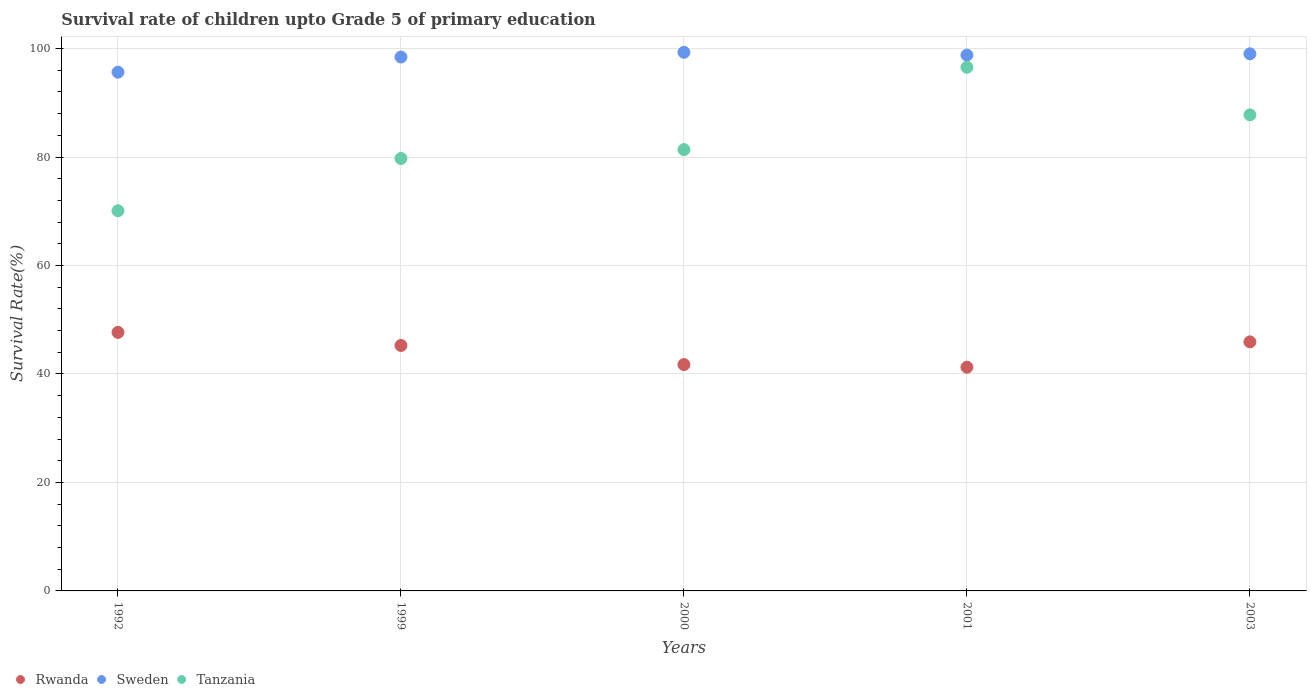What is the survival rate of children in Sweden in 2001?
Make the answer very short. 98.79. Across all years, what is the maximum survival rate of children in Tanzania?
Provide a short and direct response. 96.54. Across all years, what is the minimum survival rate of children in Rwanda?
Your response must be concise. 41.25. What is the total survival rate of children in Sweden in the graph?
Make the answer very short. 491.19. What is the difference between the survival rate of children in Sweden in 1992 and that in 2000?
Provide a succinct answer. -3.66. What is the difference between the survival rate of children in Rwanda in 1992 and the survival rate of children in Tanzania in 1999?
Keep it short and to the point. -32.06. What is the average survival rate of children in Tanzania per year?
Provide a short and direct response. 83.1. In the year 1992, what is the difference between the survival rate of children in Rwanda and survival rate of children in Sweden?
Your response must be concise. -47.97. In how many years, is the survival rate of children in Rwanda greater than 12 %?
Your answer should be compact. 5. What is the ratio of the survival rate of children in Tanzania in 2000 to that in 2003?
Make the answer very short. 0.93. What is the difference between the highest and the second highest survival rate of children in Rwanda?
Provide a succinct answer. 1.75. What is the difference between the highest and the lowest survival rate of children in Tanzania?
Give a very brief answer. 26.45. In how many years, is the survival rate of children in Sweden greater than the average survival rate of children in Sweden taken over all years?
Offer a terse response. 4. Is the sum of the survival rate of children in Tanzania in 1999 and 2000 greater than the maximum survival rate of children in Rwanda across all years?
Ensure brevity in your answer.  Yes. Is the survival rate of children in Tanzania strictly greater than the survival rate of children in Sweden over the years?
Make the answer very short. No. Is the survival rate of children in Tanzania strictly less than the survival rate of children in Sweden over the years?
Your response must be concise. Yes. How many dotlines are there?
Provide a succinct answer. 3. Does the graph contain grids?
Offer a terse response. Yes. How are the legend labels stacked?
Your answer should be very brief. Horizontal. What is the title of the graph?
Provide a succinct answer. Survival rate of children upto Grade 5 of primary education. What is the label or title of the Y-axis?
Your answer should be very brief. Survival Rate(%). What is the Survival Rate(%) in Rwanda in 1992?
Offer a terse response. 47.67. What is the Survival Rate(%) of Sweden in 1992?
Your response must be concise. 95.64. What is the Survival Rate(%) of Tanzania in 1992?
Provide a short and direct response. 70.09. What is the Survival Rate(%) of Rwanda in 1999?
Your answer should be compact. 45.26. What is the Survival Rate(%) of Sweden in 1999?
Your answer should be very brief. 98.43. What is the Survival Rate(%) in Tanzania in 1999?
Your answer should be compact. 79.73. What is the Survival Rate(%) in Rwanda in 2000?
Provide a succinct answer. 41.73. What is the Survival Rate(%) of Sweden in 2000?
Give a very brief answer. 99.3. What is the Survival Rate(%) in Tanzania in 2000?
Your response must be concise. 81.36. What is the Survival Rate(%) of Rwanda in 2001?
Offer a very short reply. 41.25. What is the Survival Rate(%) in Sweden in 2001?
Keep it short and to the point. 98.79. What is the Survival Rate(%) of Tanzania in 2001?
Provide a succinct answer. 96.54. What is the Survival Rate(%) in Rwanda in 2003?
Your answer should be compact. 45.92. What is the Survival Rate(%) of Sweden in 2003?
Make the answer very short. 99.02. What is the Survival Rate(%) of Tanzania in 2003?
Provide a short and direct response. 87.77. Across all years, what is the maximum Survival Rate(%) in Rwanda?
Provide a succinct answer. 47.67. Across all years, what is the maximum Survival Rate(%) in Sweden?
Offer a very short reply. 99.3. Across all years, what is the maximum Survival Rate(%) in Tanzania?
Offer a terse response. 96.54. Across all years, what is the minimum Survival Rate(%) of Rwanda?
Give a very brief answer. 41.25. Across all years, what is the minimum Survival Rate(%) in Sweden?
Your response must be concise. 95.64. Across all years, what is the minimum Survival Rate(%) in Tanzania?
Your answer should be very brief. 70.09. What is the total Survival Rate(%) of Rwanda in the graph?
Offer a terse response. 221.82. What is the total Survival Rate(%) of Sweden in the graph?
Ensure brevity in your answer.  491.19. What is the total Survival Rate(%) of Tanzania in the graph?
Offer a very short reply. 415.49. What is the difference between the Survival Rate(%) of Rwanda in 1992 and that in 1999?
Provide a short and direct response. 2.41. What is the difference between the Survival Rate(%) in Sweden in 1992 and that in 1999?
Provide a short and direct response. -2.79. What is the difference between the Survival Rate(%) of Tanzania in 1992 and that in 1999?
Your response must be concise. -9.64. What is the difference between the Survival Rate(%) of Rwanda in 1992 and that in 2000?
Offer a terse response. 5.93. What is the difference between the Survival Rate(%) of Sweden in 1992 and that in 2000?
Provide a succinct answer. -3.66. What is the difference between the Survival Rate(%) of Tanzania in 1992 and that in 2000?
Provide a succinct answer. -11.27. What is the difference between the Survival Rate(%) in Rwanda in 1992 and that in 2001?
Give a very brief answer. 6.42. What is the difference between the Survival Rate(%) of Sweden in 1992 and that in 2001?
Provide a short and direct response. -3.15. What is the difference between the Survival Rate(%) in Tanzania in 1992 and that in 2001?
Provide a short and direct response. -26.45. What is the difference between the Survival Rate(%) of Rwanda in 1992 and that in 2003?
Provide a short and direct response. 1.75. What is the difference between the Survival Rate(%) of Sweden in 1992 and that in 2003?
Offer a very short reply. -3.38. What is the difference between the Survival Rate(%) in Tanzania in 1992 and that in 2003?
Your answer should be very brief. -17.68. What is the difference between the Survival Rate(%) in Rwanda in 1999 and that in 2000?
Keep it short and to the point. 3.52. What is the difference between the Survival Rate(%) in Sweden in 1999 and that in 2000?
Provide a short and direct response. -0.87. What is the difference between the Survival Rate(%) of Tanzania in 1999 and that in 2000?
Provide a succinct answer. -1.63. What is the difference between the Survival Rate(%) in Rwanda in 1999 and that in 2001?
Provide a short and direct response. 4.01. What is the difference between the Survival Rate(%) in Sweden in 1999 and that in 2001?
Offer a very short reply. -0.36. What is the difference between the Survival Rate(%) in Tanzania in 1999 and that in 2001?
Your response must be concise. -16.81. What is the difference between the Survival Rate(%) in Rwanda in 1999 and that in 2003?
Provide a short and direct response. -0.66. What is the difference between the Survival Rate(%) of Sweden in 1999 and that in 2003?
Provide a succinct answer. -0.59. What is the difference between the Survival Rate(%) in Tanzania in 1999 and that in 2003?
Offer a terse response. -8.04. What is the difference between the Survival Rate(%) in Rwanda in 2000 and that in 2001?
Make the answer very short. 0.48. What is the difference between the Survival Rate(%) in Sweden in 2000 and that in 2001?
Your answer should be very brief. 0.51. What is the difference between the Survival Rate(%) in Tanzania in 2000 and that in 2001?
Your answer should be very brief. -15.18. What is the difference between the Survival Rate(%) of Rwanda in 2000 and that in 2003?
Make the answer very short. -4.18. What is the difference between the Survival Rate(%) in Sweden in 2000 and that in 2003?
Provide a succinct answer. 0.28. What is the difference between the Survival Rate(%) in Tanzania in 2000 and that in 2003?
Keep it short and to the point. -6.41. What is the difference between the Survival Rate(%) in Rwanda in 2001 and that in 2003?
Your answer should be very brief. -4.67. What is the difference between the Survival Rate(%) of Sweden in 2001 and that in 2003?
Give a very brief answer. -0.24. What is the difference between the Survival Rate(%) of Tanzania in 2001 and that in 2003?
Your response must be concise. 8.77. What is the difference between the Survival Rate(%) in Rwanda in 1992 and the Survival Rate(%) in Sweden in 1999?
Provide a short and direct response. -50.77. What is the difference between the Survival Rate(%) of Rwanda in 1992 and the Survival Rate(%) of Tanzania in 1999?
Ensure brevity in your answer.  -32.06. What is the difference between the Survival Rate(%) in Sweden in 1992 and the Survival Rate(%) in Tanzania in 1999?
Give a very brief answer. 15.91. What is the difference between the Survival Rate(%) in Rwanda in 1992 and the Survival Rate(%) in Sweden in 2000?
Your answer should be very brief. -51.63. What is the difference between the Survival Rate(%) in Rwanda in 1992 and the Survival Rate(%) in Tanzania in 2000?
Provide a succinct answer. -33.69. What is the difference between the Survival Rate(%) of Sweden in 1992 and the Survival Rate(%) of Tanzania in 2000?
Offer a terse response. 14.28. What is the difference between the Survival Rate(%) of Rwanda in 1992 and the Survival Rate(%) of Sweden in 2001?
Your answer should be very brief. -51.12. What is the difference between the Survival Rate(%) of Rwanda in 1992 and the Survival Rate(%) of Tanzania in 2001?
Ensure brevity in your answer.  -48.88. What is the difference between the Survival Rate(%) in Sweden in 1992 and the Survival Rate(%) in Tanzania in 2001?
Offer a terse response. -0.9. What is the difference between the Survival Rate(%) in Rwanda in 1992 and the Survival Rate(%) in Sweden in 2003?
Your answer should be compact. -51.36. What is the difference between the Survival Rate(%) of Rwanda in 1992 and the Survival Rate(%) of Tanzania in 2003?
Make the answer very short. -40.1. What is the difference between the Survival Rate(%) in Sweden in 1992 and the Survival Rate(%) in Tanzania in 2003?
Provide a short and direct response. 7.87. What is the difference between the Survival Rate(%) in Rwanda in 1999 and the Survival Rate(%) in Sweden in 2000?
Offer a very short reply. -54.04. What is the difference between the Survival Rate(%) in Rwanda in 1999 and the Survival Rate(%) in Tanzania in 2000?
Provide a succinct answer. -36.1. What is the difference between the Survival Rate(%) in Sweden in 1999 and the Survival Rate(%) in Tanzania in 2000?
Provide a short and direct response. 17.07. What is the difference between the Survival Rate(%) of Rwanda in 1999 and the Survival Rate(%) of Sweden in 2001?
Your answer should be compact. -53.53. What is the difference between the Survival Rate(%) in Rwanda in 1999 and the Survival Rate(%) in Tanzania in 2001?
Your answer should be very brief. -51.29. What is the difference between the Survival Rate(%) in Sweden in 1999 and the Survival Rate(%) in Tanzania in 2001?
Make the answer very short. 1.89. What is the difference between the Survival Rate(%) of Rwanda in 1999 and the Survival Rate(%) of Sweden in 2003?
Keep it short and to the point. -53.77. What is the difference between the Survival Rate(%) in Rwanda in 1999 and the Survival Rate(%) in Tanzania in 2003?
Keep it short and to the point. -42.51. What is the difference between the Survival Rate(%) in Sweden in 1999 and the Survival Rate(%) in Tanzania in 2003?
Give a very brief answer. 10.67. What is the difference between the Survival Rate(%) of Rwanda in 2000 and the Survival Rate(%) of Sweden in 2001?
Your answer should be very brief. -57.06. What is the difference between the Survival Rate(%) in Rwanda in 2000 and the Survival Rate(%) in Tanzania in 2001?
Provide a short and direct response. -54.81. What is the difference between the Survival Rate(%) of Sweden in 2000 and the Survival Rate(%) of Tanzania in 2001?
Provide a short and direct response. 2.76. What is the difference between the Survival Rate(%) in Rwanda in 2000 and the Survival Rate(%) in Sweden in 2003?
Keep it short and to the point. -57.29. What is the difference between the Survival Rate(%) in Rwanda in 2000 and the Survival Rate(%) in Tanzania in 2003?
Your answer should be very brief. -46.04. What is the difference between the Survival Rate(%) of Sweden in 2000 and the Survival Rate(%) of Tanzania in 2003?
Keep it short and to the point. 11.53. What is the difference between the Survival Rate(%) of Rwanda in 2001 and the Survival Rate(%) of Sweden in 2003?
Your answer should be very brief. -57.78. What is the difference between the Survival Rate(%) in Rwanda in 2001 and the Survival Rate(%) in Tanzania in 2003?
Provide a succinct answer. -46.52. What is the difference between the Survival Rate(%) of Sweden in 2001 and the Survival Rate(%) of Tanzania in 2003?
Provide a succinct answer. 11.02. What is the average Survival Rate(%) of Rwanda per year?
Make the answer very short. 44.36. What is the average Survival Rate(%) of Sweden per year?
Ensure brevity in your answer.  98.24. What is the average Survival Rate(%) in Tanzania per year?
Provide a succinct answer. 83.1. In the year 1992, what is the difference between the Survival Rate(%) in Rwanda and Survival Rate(%) in Sweden?
Your response must be concise. -47.97. In the year 1992, what is the difference between the Survival Rate(%) in Rwanda and Survival Rate(%) in Tanzania?
Your response must be concise. -22.42. In the year 1992, what is the difference between the Survival Rate(%) in Sweden and Survival Rate(%) in Tanzania?
Ensure brevity in your answer.  25.55. In the year 1999, what is the difference between the Survival Rate(%) in Rwanda and Survival Rate(%) in Sweden?
Provide a short and direct response. -53.18. In the year 1999, what is the difference between the Survival Rate(%) of Rwanda and Survival Rate(%) of Tanzania?
Provide a short and direct response. -34.47. In the year 1999, what is the difference between the Survival Rate(%) of Sweden and Survival Rate(%) of Tanzania?
Provide a short and direct response. 18.71. In the year 2000, what is the difference between the Survival Rate(%) of Rwanda and Survival Rate(%) of Sweden?
Make the answer very short. -57.57. In the year 2000, what is the difference between the Survival Rate(%) in Rwanda and Survival Rate(%) in Tanzania?
Your response must be concise. -39.63. In the year 2000, what is the difference between the Survival Rate(%) in Sweden and Survival Rate(%) in Tanzania?
Make the answer very short. 17.94. In the year 2001, what is the difference between the Survival Rate(%) in Rwanda and Survival Rate(%) in Sweden?
Make the answer very short. -57.54. In the year 2001, what is the difference between the Survival Rate(%) of Rwanda and Survival Rate(%) of Tanzania?
Keep it short and to the point. -55.29. In the year 2001, what is the difference between the Survival Rate(%) in Sweden and Survival Rate(%) in Tanzania?
Your response must be concise. 2.25. In the year 2003, what is the difference between the Survival Rate(%) of Rwanda and Survival Rate(%) of Sweden?
Keep it short and to the point. -53.11. In the year 2003, what is the difference between the Survival Rate(%) in Rwanda and Survival Rate(%) in Tanzania?
Your response must be concise. -41.85. In the year 2003, what is the difference between the Survival Rate(%) of Sweden and Survival Rate(%) of Tanzania?
Your answer should be compact. 11.26. What is the ratio of the Survival Rate(%) of Rwanda in 1992 to that in 1999?
Ensure brevity in your answer.  1.05. What is the ratio of the Survival Rate(%) in Sweden in 1992 to that in 1999?
Your answer should be very brief. 0.97. What is the ratio of the Survival Rate(%) in Tanzania in 1992 to that in 1999?
Your answer should be very brief. 0.88. What is the ratio of the Survival Rate(%) in Rwanda in 1992 to that in 2000?
Your answer should be compact. 1.14. What is the ratio of the Survival Rate(%) in Sweden in 1992 to that in 2000?
Make the answer very short. 0.96. What is the ratio of the Survival Rate(%) in Tanzania in 1992 to that in 2000?
Make the answer very short. 0.86. What is the ratio of the Survival Rate(%) of Rwanda in 1992 to that in 2001?
Your response must be concise. 1.16. What is the ratio of the Survival Rate(%) of Sweden in 1992 to that in 2001?
Keep it short and to the point. 0.97. What is the ratio of the Survival Rate(%) of Tanzania in 1992 to that in 2001?
Offer a terse response. 0.73. What is the ratio of the Survival Rate(%) of Rwanda in 1992 to that in 2003?
Your response must be concise. 1.04. What is the ratio of the Survival Rate(%) of Sweden in 1992 to that in 2003?
Ensure brevity in your answer.  0.97. What is the ratio of the Survival Rate(%) in Tanzania in 1992 to that in 2003?
Offer a terse response. 0.8. What is the ratio of the Survival Rate(%) in Rwanda in 1999 to that in 2000?
Your answer should be very brief. 1.08. What is the ratio of the Survival Rate(%) in Tanzania in 1999 to that in 2000?
Your answer should be compact. 0.98. What is the ratio of the Survival Rate(%) in Rwanda in 1999 to that in 2001?
Your answer should be compact. 1.1. What is the ratio of the Survival Rate(%) of Sweden in 1999 to that in 2001?
Your response must be concise. 1. What is the ratio of the Survival Rate(%) of Tanzania in 1999 to that in 2001?
Offer a terse response. 0.83. What is the ratio of the Survival Rate(%) of Rwanda in 1999 to that in 2003?
Offer a terse response. 0.99. What is the ratio of the Survival Rate(%) in Sweden in 1999 to that in 2003?
Make the answer very short. 0.99. What is the ratio of the Survival Rate(%) in Tanzania in 1999 to that in 2003?
Offer a very short reply. 0.91. What is the ratio of the Survival Rate(%) in Rwanda in 2000 to that in 2001?
Provide a succinct answer. 1.01. What is the ratio of the Survival Rate(%) of Sweden in 2000 to that in 2001?
Keep it short and to the point. 1.01. What is the ratio of the Survival Rate(%) of Tanzania in 2000 to that in 2001?
Provide a succinct answer. 0.84. What is the ratio of the Survival Rate(%) in Rwanda in 2000 to that in 2003?
Make the answer very short. 0.91. What is the ratio of the Survival Rate(%) in Tanzania in 2000 to that in 2003?
Your answer should be very brief. 0.93. What is the ratio of the Survival Rate(%) in Rwanda in 2001 to that in 2003?
Make the answer very short. 0.9. What is the ratio of the Survival Rate(%) in Tanzania in 2001 to that in 2003?
Make the answer very short. 1.1. What is the difference between the highest and the second highest Survival Rate(%) in Rwanda?
Provide a short and direct response. 1.75. What is the difference between the highest and the second highest Survival Rate(%) in Sweden?
Offer a terse response. 0.28. What is the difference between the highest and the second highest Survival Rate(%) of Tanzania?
Give a very brief answer. 8.77. What is the difference between the highest and the lowest Survival Rate(%) of Rwanda?
Your answer should be very brief. 6.42. What is the difference between the highest and the lowest Survival Rate(%) in Sweden?
Make the answer very short. 3.66. What is the difference between the highest and the lowest Survival Rate(%) of Tanzania?
Your answer should be compact. 26.45. 